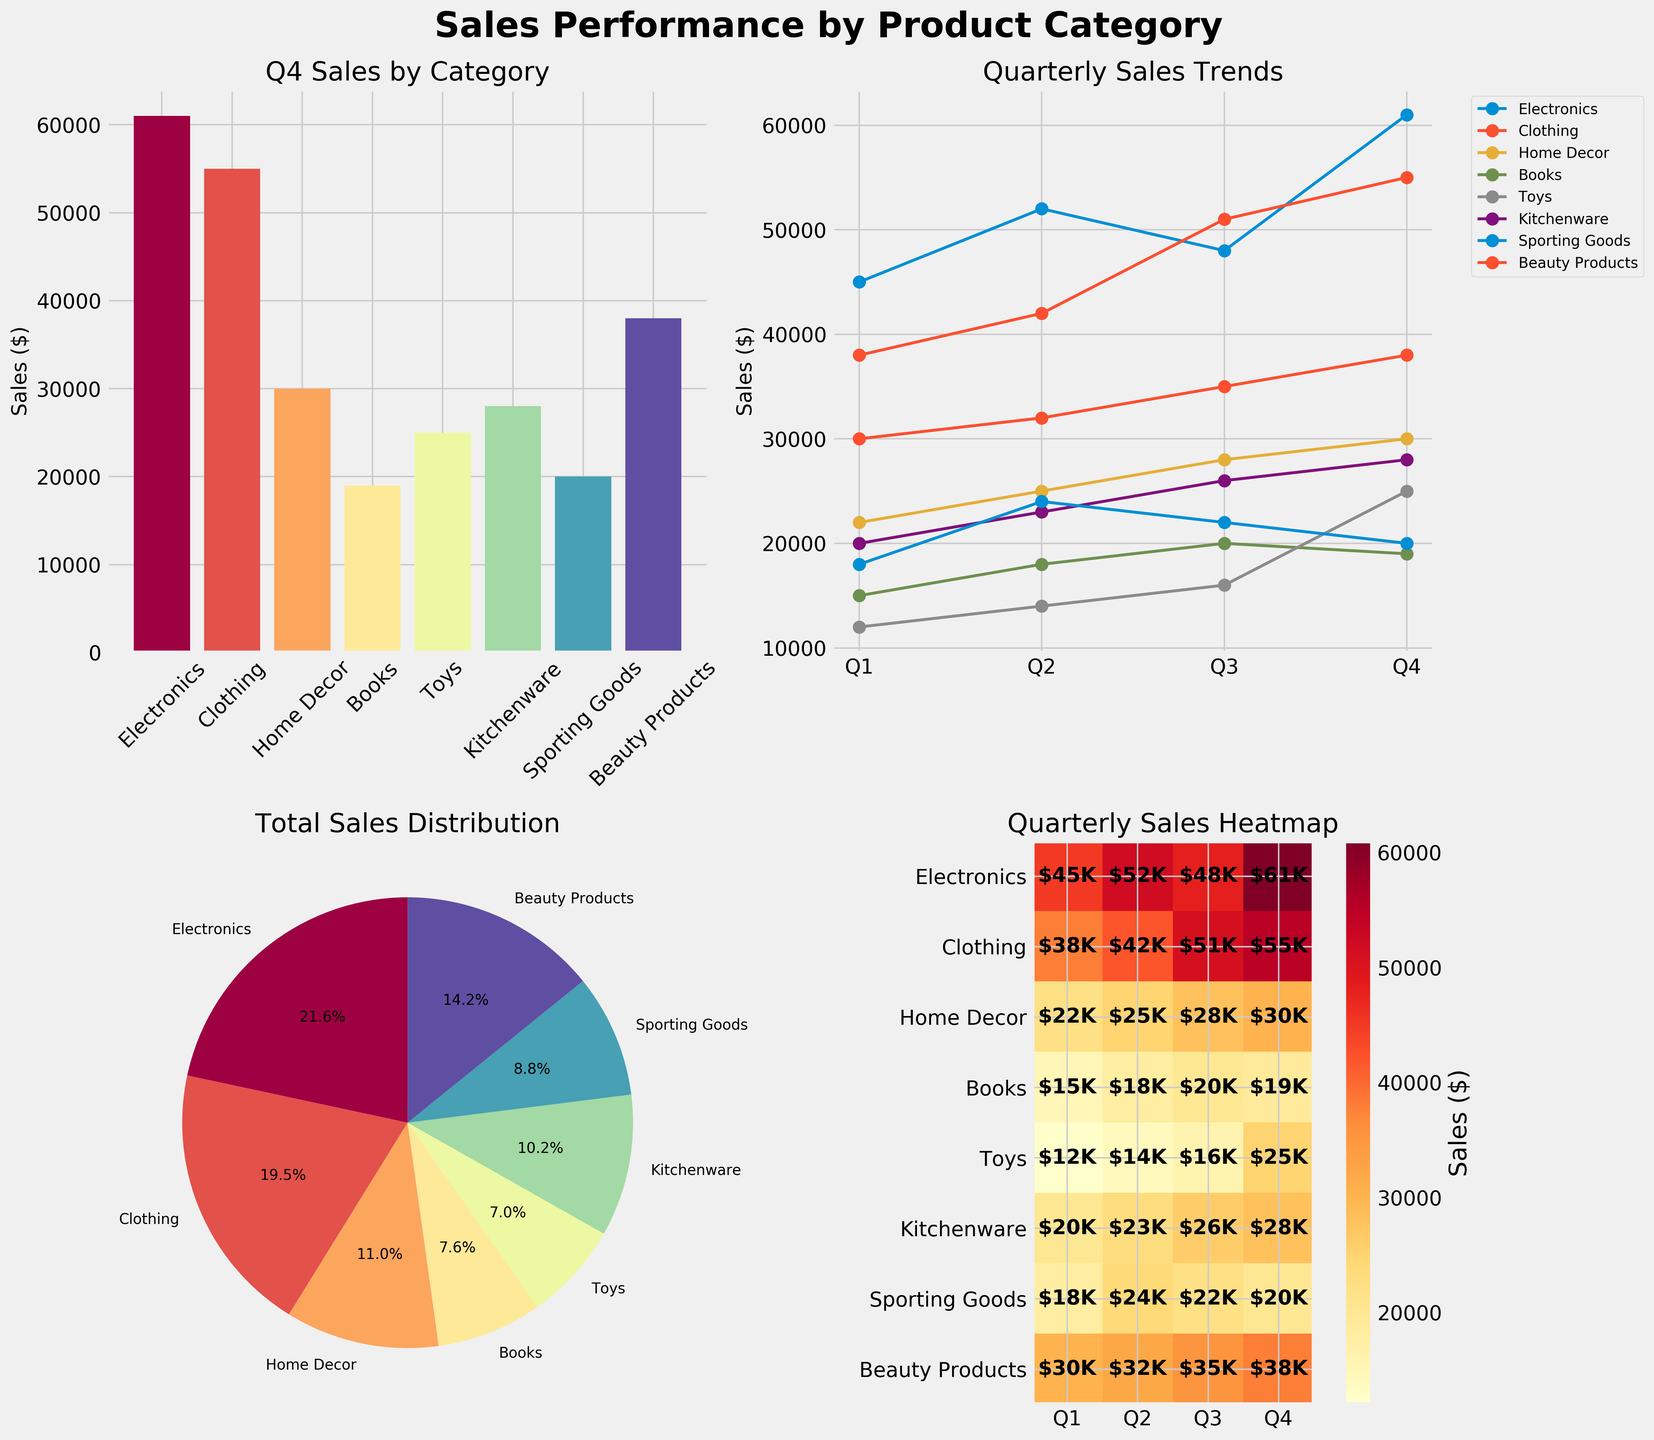what is the sales amount for Electronics in Q4? Look at the bar plot for Q4 sales, find the bar labeled "Electronics" and check its height.
Answer: $61,000 which category has the lowest total sales? Look at the pie chart that represents the total sales distribution. The smallest slice corresponds to Books, indicating the lowest total sales.
Answer: Books how much more did Clothing sell in Q4 compared to Q1? From the bar plot and the line plot, locate the sales figures for Clothing in Q1 and Q4. Calculate the difference: Q4 ($55,000) - Q1 ($38,000) = $17,000.
Answer: $17,000 which category had the biggest increase in sales from Q3 to Q4? Examine the line plot, looking for the steepest upward slope between Q3 and Q4. Toys show a significant rise from $16,000 in Q3 to $25,000 in Q4.
Answer: Toys what is the general trend in sales for Beauty Products over the quarters? Refer to the line plot for Beauty Products and observe the trend. The sales steadily increase from $30,000 in Q1 to $38,000 in Q4.
Answer: Increasing which two categories have the closest sales figures in Q2? From the bar plot, identify the sales figures for all categories in Q2 and find the two with the smallest difference. Home Decor and Kitchenware are close, with $25,000 and $23,000 respectively.
Answer: Home Decor and Kitchenware what percentage of total sales is represented by Electronics? Based on the pie chart, find the slice labeled Electronics and check its percentage. Electronics represent 25.8% of the total sales.
Answer: 25.8% what do the darkest colors in the heatmap represent? Observe the heatmap color scale. The darkest colors correspond to the highest sales values, such as $61,000 for Electronics in Q4.
Answer: Highest sales values which category had the least variation in sales over the quarters? Find the category with the most stable line in the line plot. Books have the least variation with sales ranging from $15,000 to $20,000.
Answer: Books how do the Q4 sales of Kitchenware compare to Sporting Goods? Look at the Q4 bars for both categories. Kitchenware sales are $28,000, and Sporting Goods sales are $20,000, showing Kitchenware has higher Q4 sales.
Answer: Kitchenware is higher 